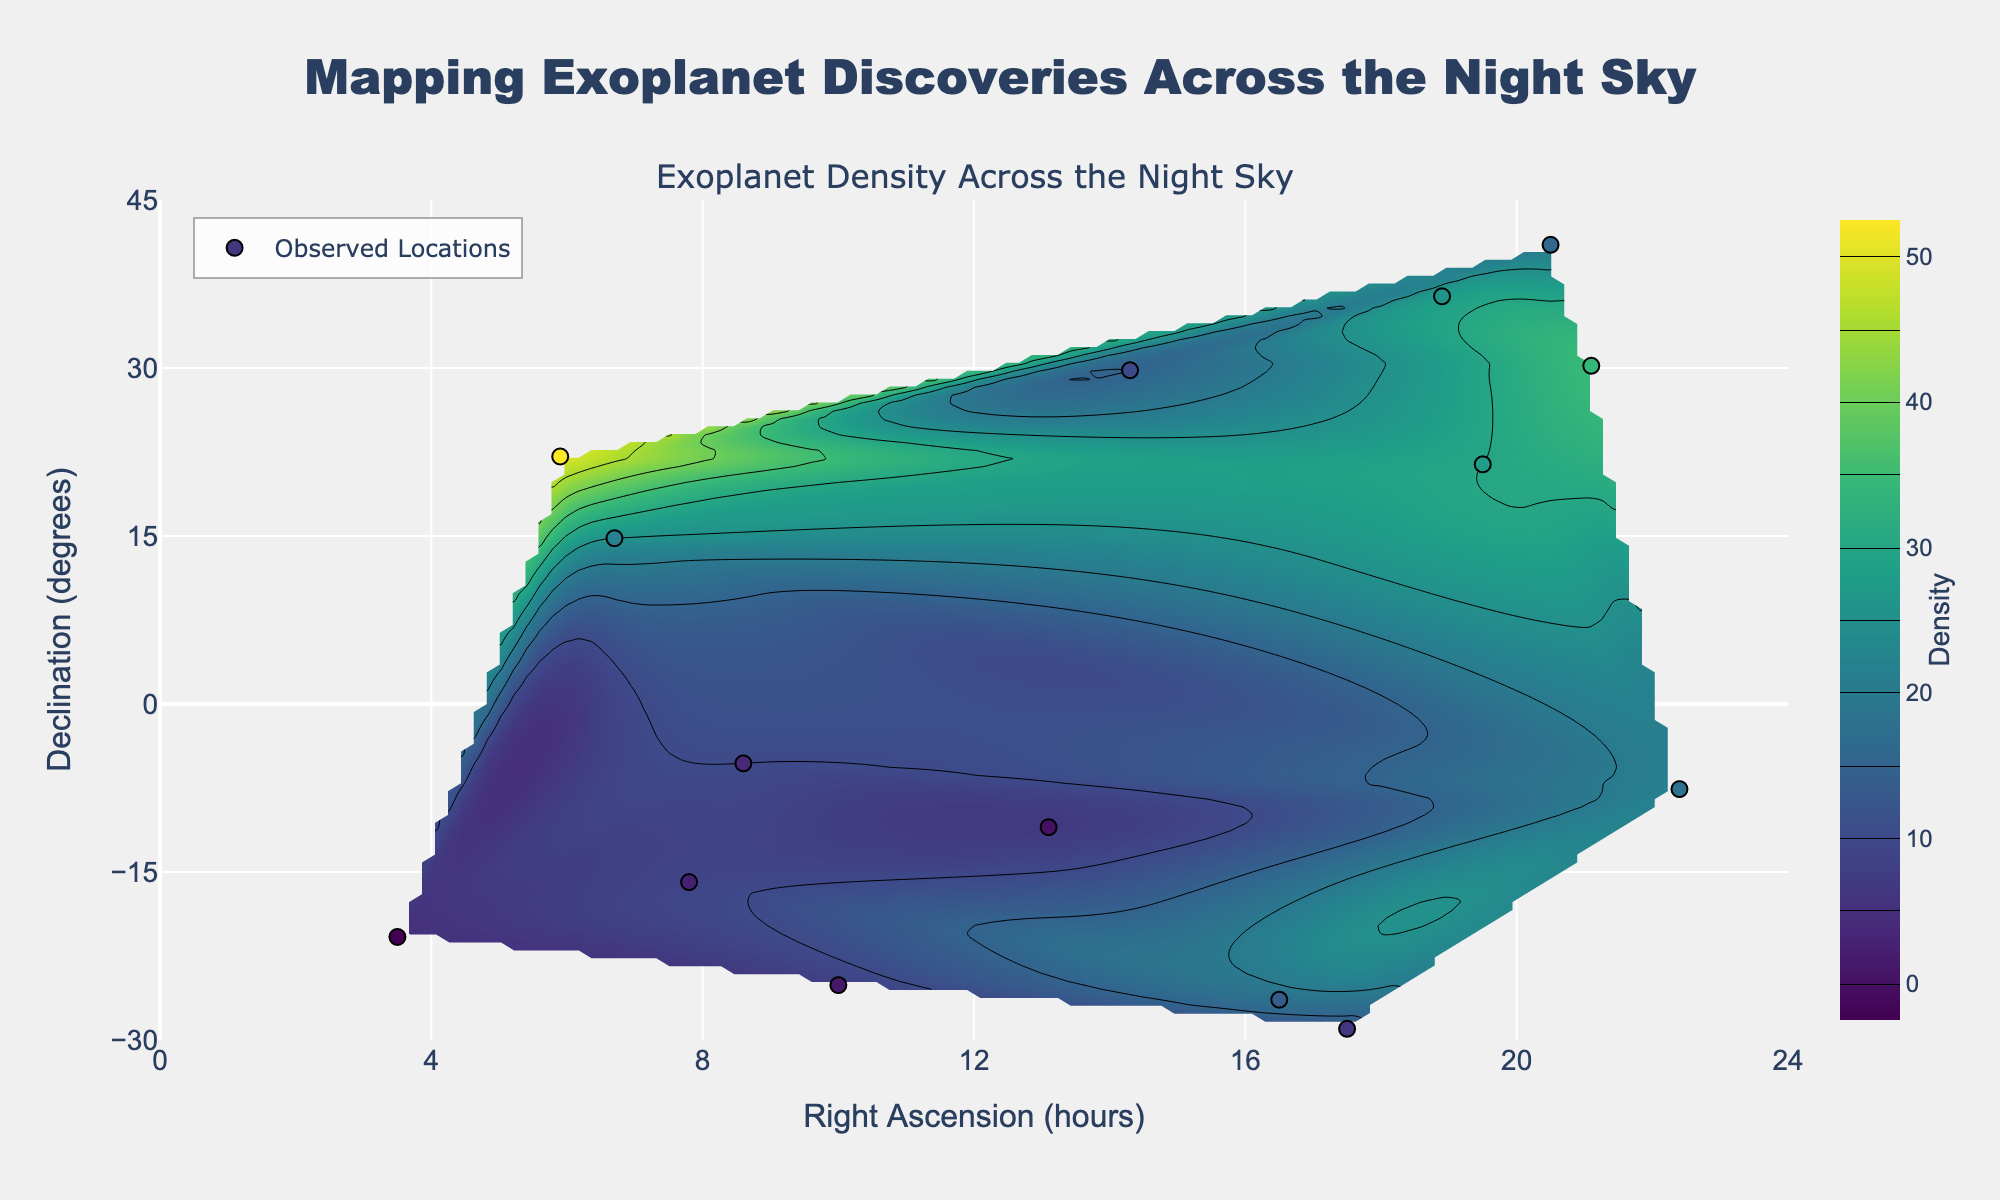What is the title of the figure? The title is displayed at the top center of the figure, written in a large font.
Answer: "Mapping Exoplanet Discoveries Across the Night Sky" What is the highest exoplanet density visible in the density color bar? The color bar on the right indicates the range of densities from 0 to 50. The highest value shown is 50.
Answer: 50 How many observed locations of exoplanet discoveries are there in total? The scatter plot shows individual points for each observed location. Counting these points will give the total number of locations.
Answer: 15 Which region in Right Ascension (RA) contains the highest density of exoplanet discoveries? By observing the contour plot with the Viridis color scale, we see the brightest (yellow) region around RA 5.9. The highest density of 50 is there.
Answer: Around 5.9 hours In which range of Declination (Dec) is the highest density of exoplanet discoveries located? The contour plot shows the highest density at Declination around 22.1 degrees, matching the observed location with the highest density.
Answer: Around 22.1 degrees Which data point has the lowest exoplanet density? By inspecting the scatter plot, the data point at RA 3.5 and Dec -20.8 has the lowest density value of 5.
Answer: RA 3.5, Dec -20.8 Compare the density of exoplanet discoveries between RA 19.5 and RA 18.9. Which one is higher and by how much? The scatter plot shows densities of 30 at RA 19.5 and 28 at RA 18.9. The difference is 30 - 28 = 2.
Answer: RA 19.5 is higher by 2 What is the range of Right Ascension (RA) covered in this figure? This information can be seen from the x-axis of the contour plot, ranging from 0 to 24 hours.
Answer: 0 to 24 hours Compare the exoplanet densities in RA 6.7, Dec 14.8, and RA 21.1, Dec 30.2. Which one has a higher density? The densities for these points are 25 and 35 respectively, as shown by the scatter plot.
Answer: RA 21.1, Dec 30.2 Identify the region with the second highest exoplanet density. After the highest density region around RA 5.9, Dec 22.1 (density 50), the second highest density is shown near RA 21.1, Dec 30.2 with a density of 35.
Answer: Around RA 21.1, Dec 30.2 